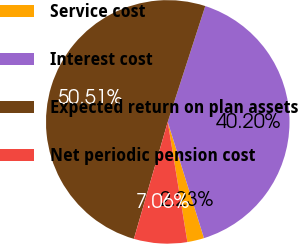Convert chart to OTSL. <chart><loc_0><loc_0><loc_500><loc_500><pie_chart><fcel>Service cost<fcel>Interest cost<fcel>Expected return on plan assets<fcel>Net periodic pension cost<nl><fcel>2.23%<fcel>40.2%<fcel>50.5%<fcel>7.06%<nl></chart> 